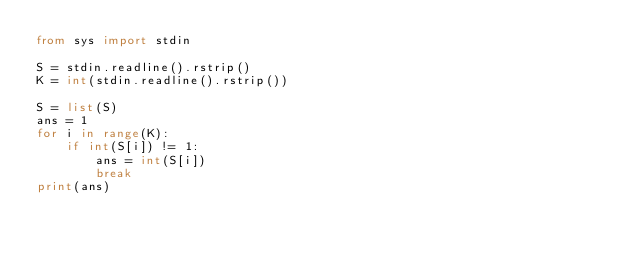<code> <loc_0><loc_0><loc_500><loc_500><_Python_>from sys import stdin

S = stdin.readline().rstrip()
K = int(stdin.readline().rstrip())

S = list(S)
ans = 1
for i in range(K):
    if int(S[i]) != 1:
        ans = int(S[i])
        break
print(ans)
</code> 